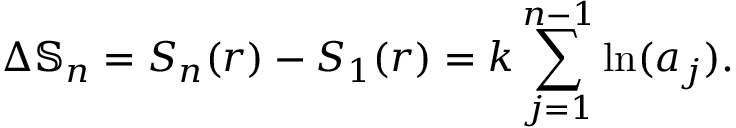Convert formula to latex. <formula><loc_0><loc_0><loc_500><loc_500>\Delta \mathbb { S } _ { n } = S _ { n } ( r ) - S _ { 1 } ( r ) = k \sum _ { j = 1 } ^ { n - 1 } \ln ( a _ { j } ) .</formula> 